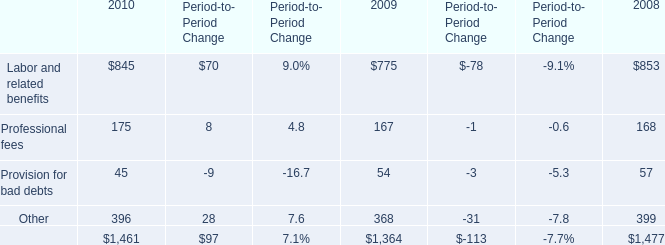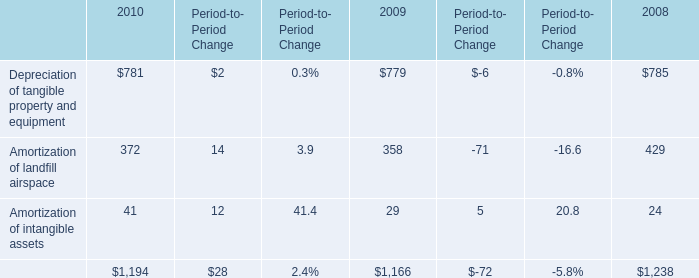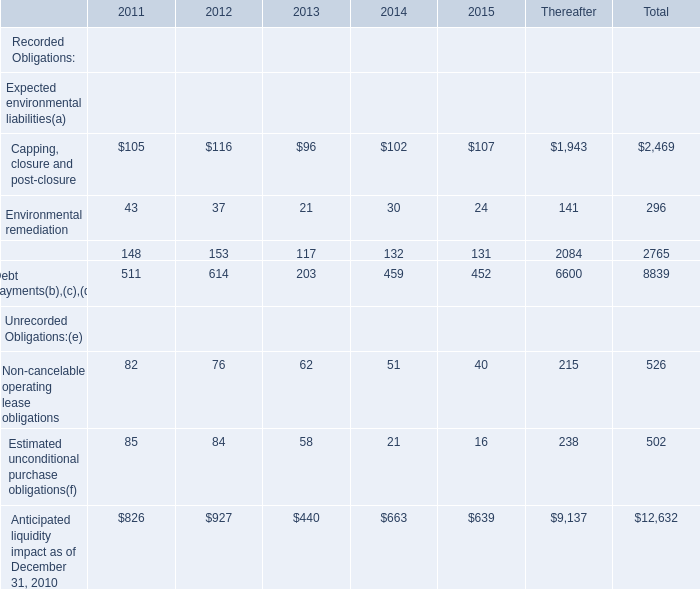Which year is Capping, closure and post-closure the most? 
Answer: 2012. 